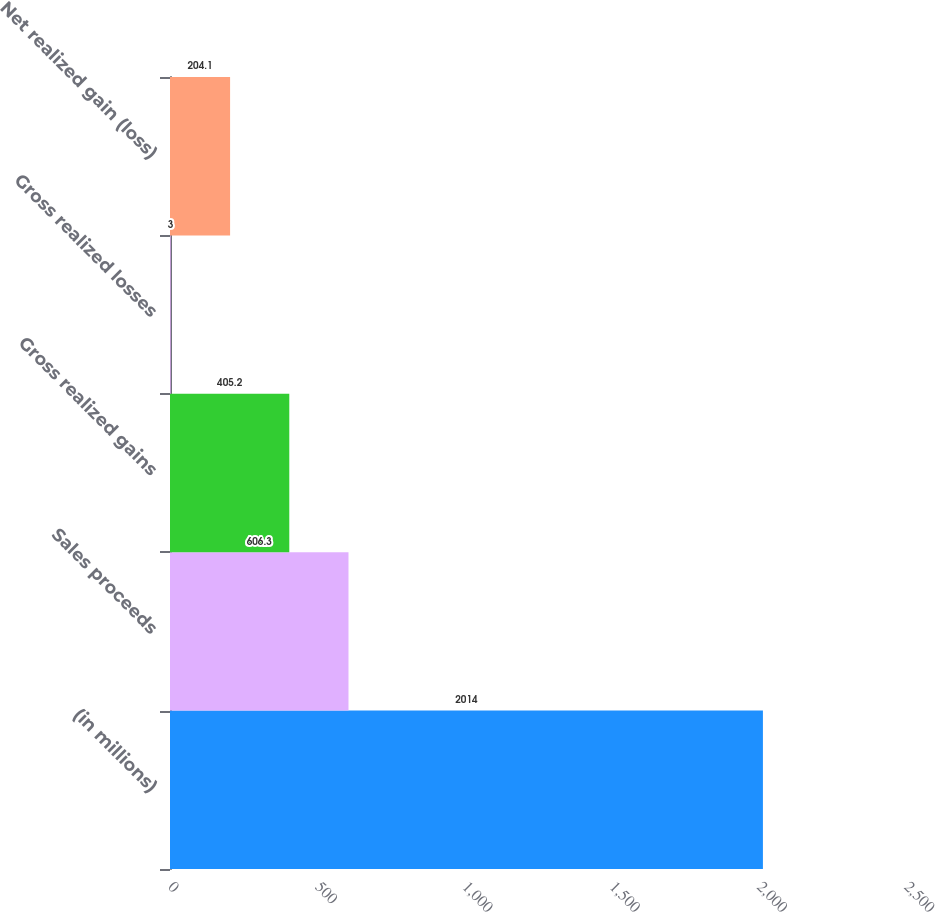Convert chart to OTSL. <chart><loc_0><loc_0><loc_500><loc_500><bar_chart><fcel>(in millions)<fcel>Sales proceeds<fcel>Gross realized gains<fcel>Gross realized losses<fcel>Net realized gain (loss)<nl><fcel>2014<fcel>606.3<fcel>405.2<fcel>3<fcel>204.1<nl></chart> 